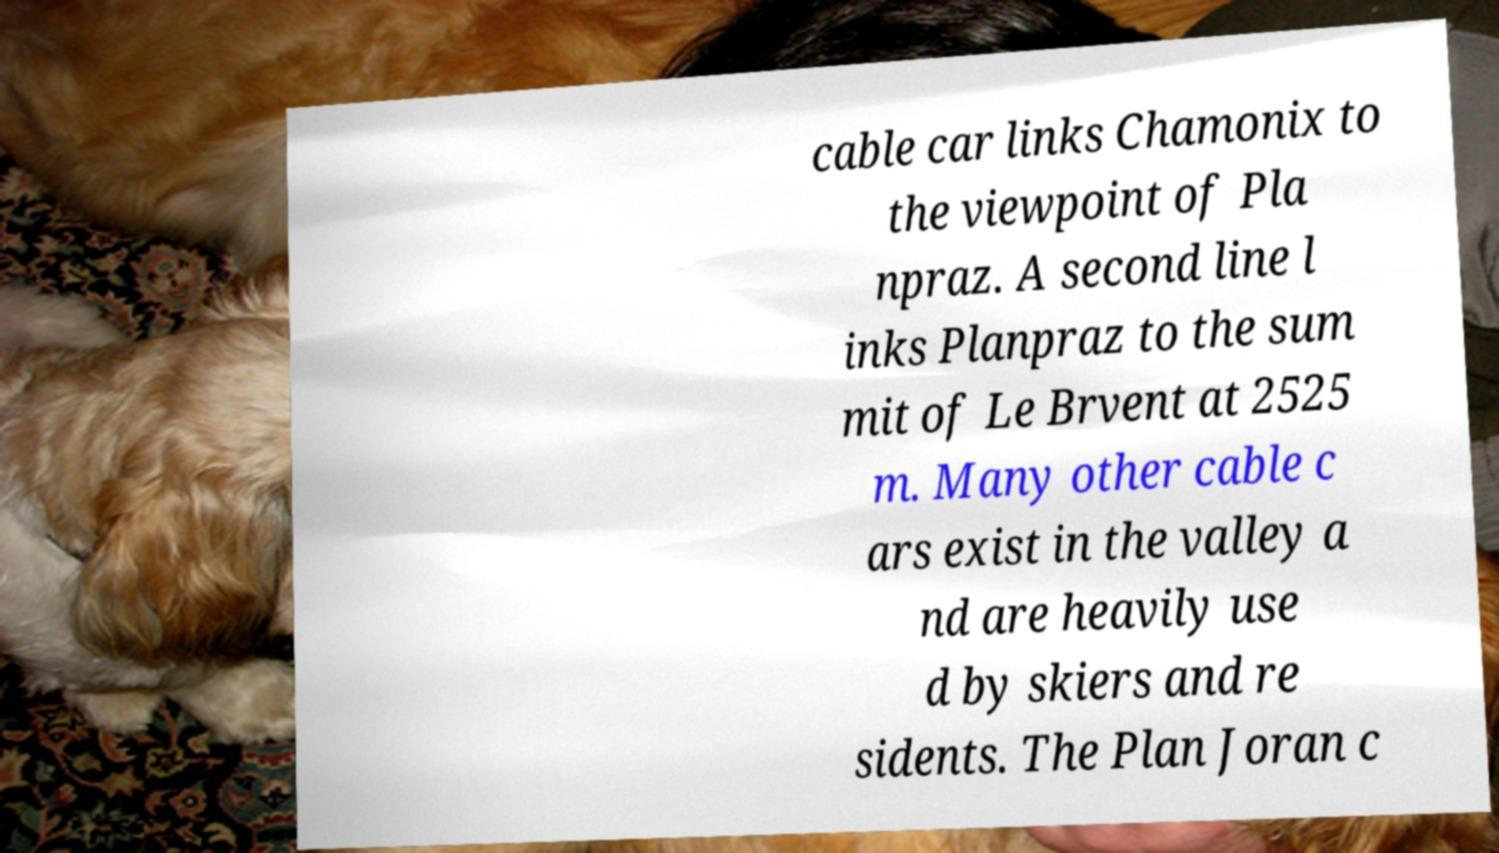Please read and relay the text visible in this image. What does it say? cable car links Chamonix to the viewpoint of Pla npraz. A second line l inks Planpraz to the sum mit of Le Brvent at 2525 m. Many other cable c ars exist in the valley a nd are heavily use d by skiers and re sidents. The Plan Joran c 